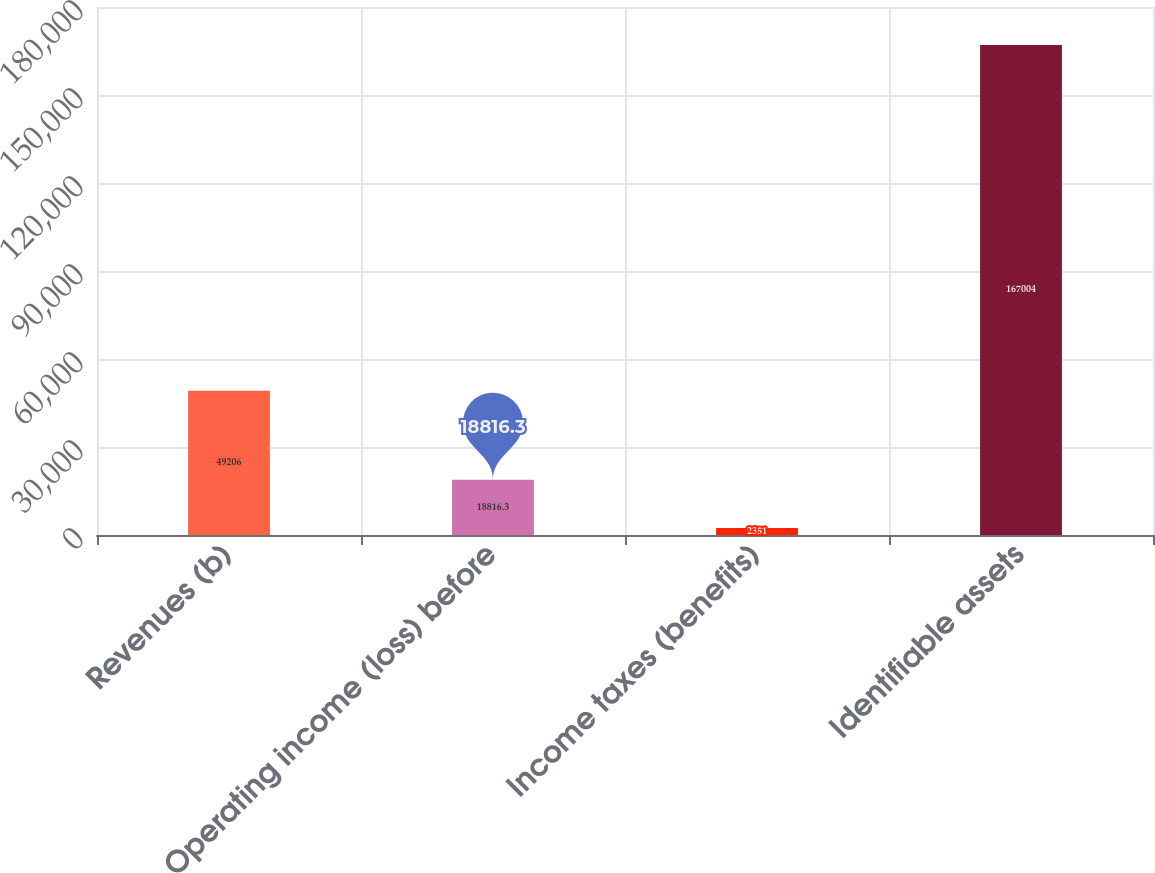<chart> <loc_0><loc_0><loc_500><loc_500><bar_chart><fcel>Revenues (b)<fcel>Operating income (loss) before<fcel>Income taxes (benefits)<fcel>Identifiable assets<nl><fcel>49206<fcel>18816.3<fcel>2351<fcel>167004<nl></chart> 